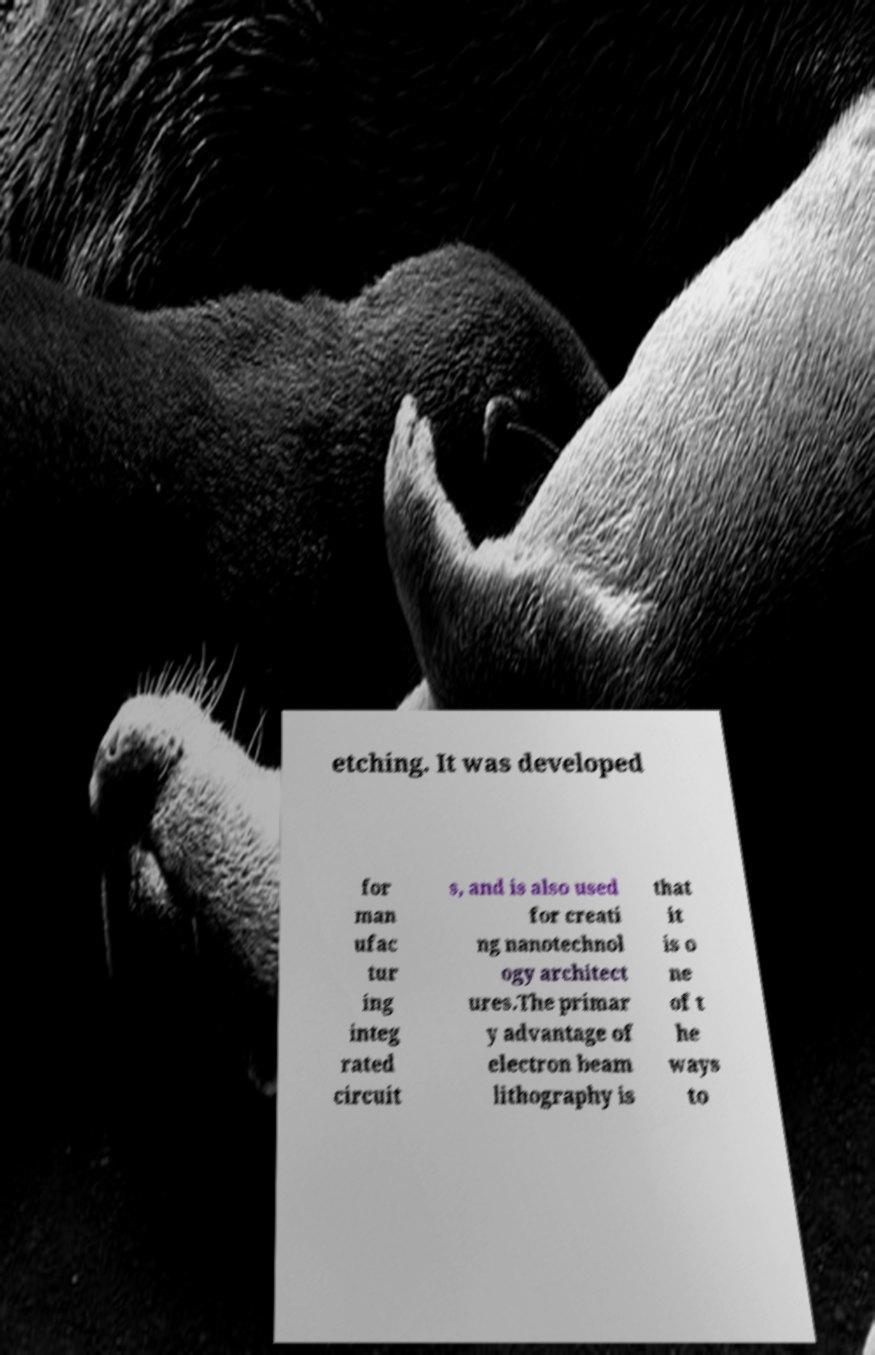Please read and relay the text visible in this image. What does it say? etching. It was developed for man ufac tur ing integ rated circuit s, and is also used for creati ng nanotechnol ogy architect ures.The primar y advantage of electron beam lithography is that it is o ne of t he ways to 